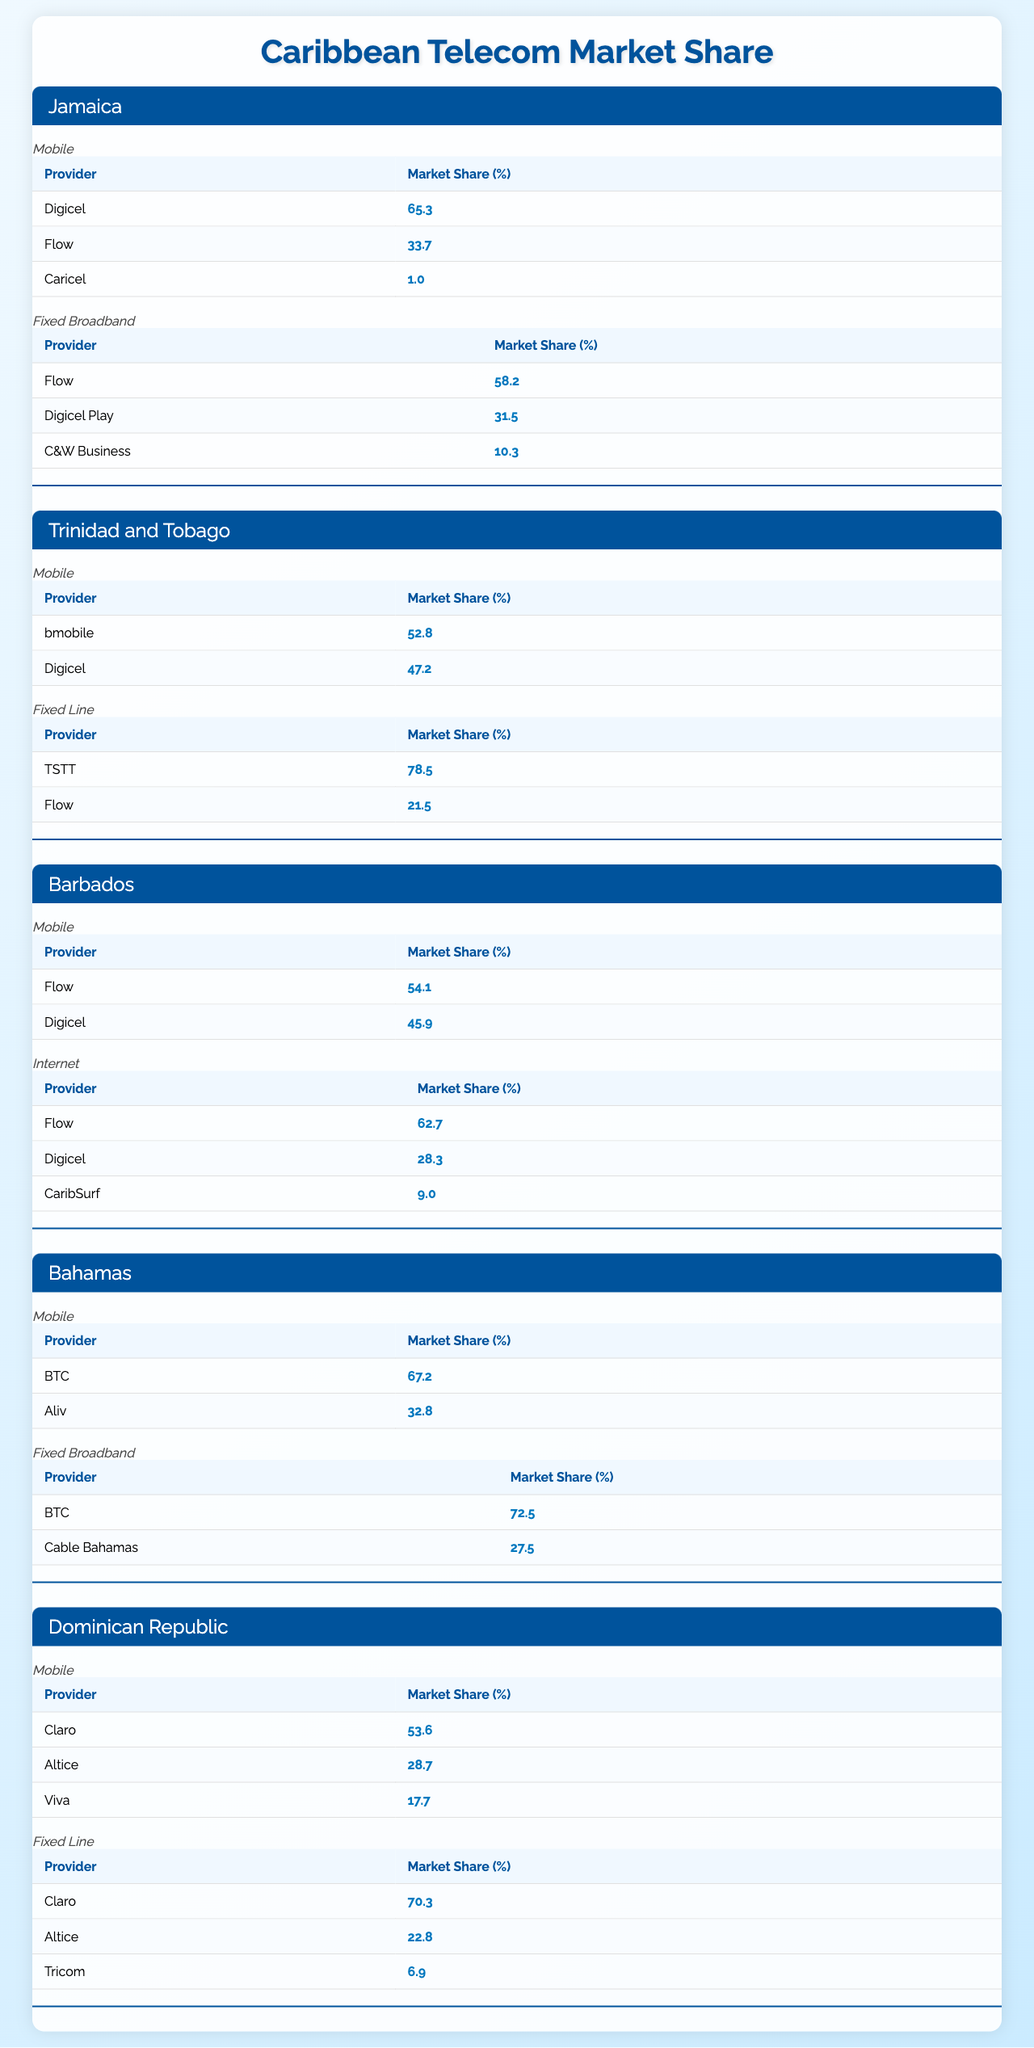What's the market share of Digicel in Jamaica's mobile service? According to the table, Digicel has a market share of 65.3% in Jamaica's mobile service.
Answer: 65.3% What is the total market share for Flow in Barbados' internet service? In the internet service section for Barbados, Flow has a market share of 62.7%.
Answer: 62.7% Is Claro the leading provider in the Dominican Republic's fixed line service? Yes, Claro has the largest market share at 70.3% for fixed line services in the Dominican Republic.
Answer: Yes Which country has the highest market share for fixed broadband services? In Jamaica, Flow leads the fixed broadband market with a 58.2% share, which is the highest among the listed countries.
Answer: Jamaica What percentage of mobile market share does Aliv have in the Bahamas? The table shows that Aliv has a 32.8% market share in the mobile service sector in the Bahamas.
Answer: 32.8% What is the combined market share of Digicel and Flow in Trinidad and Tobago's mobile market? In Trinidad and Tobago, Digicel has a 47.2% share and bmobile has a 52.8% share, for a total of 100%. Since the question asks for "Digicel and Flow," it implies Digicel only, whose share is 47.2%.
Answer: 47.2% In which country does C&W Business have a presence in fixed broadband? C&W Business is present in Jamaica's fixed broadband market with a 10.3% share.
Answer: Jamaica Calculate the difference in market share between the leading mobile providers in Trinidad and Tobago. bmobile leads with 52.8% and Digicel has 47.2%. The difference is 52.8% - 47.2% = 5.6%.
Answer: 5.6% How does the market share of Flow in fixed broadband in Jamaica compare to its market share in Barbados' mobile service? Flow holds 58.2% in fixed broadband in Jamaica and 54.1% in the mobile service in Barbados. Comparing the two, Flow's share in Jamaica is higher by 4.1%.
Answer: Jamaica's fixed broadband is higher Is the market share of Digicel in Barbados' internet services greater than that of Claro in the Dominican Republic's mobile services? Digicel holds 28.3% in Barbados' internet services, while Claro has 53.6% in the Dominican Republic's mobile market. Therefore, Claro's share is greater than Digicel's.
Answer: No 